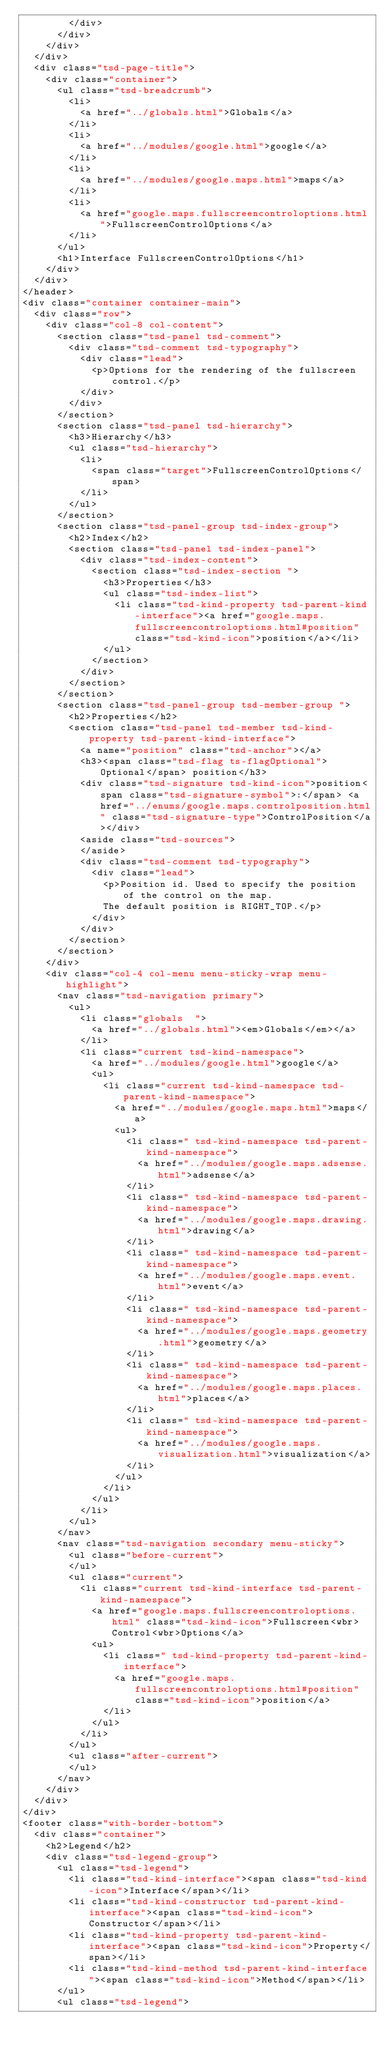<code> <loc_0><loc_0><loc_500><loc_500><_HTML_>				</div>
			</div>
		</div>
	</div>
	<div class="tsd-page-title">
		<div class="container">
			<ul class="tsd-breadcrumb">
				<li>
					<a href="../globals.html">Globals</a>
				</li>
				<li>
					<a href="../modules/google.html">google</a>
				</li>
				<li>
					<a href="../modules/google.maps.html">maps</a>
				</li>
				<li>
					<a href="google.maps.fullscreencontroloptions.html">FullscreenControlOptions</a>
				</li>
			</ul>
			<h1>Interface FullscreenControlOptions</h1>
		</div>
	</div>
</header>
<div class="container container-main">
	<div class="row">
		<div class="col-8 col-content">
			<section class="tsd-panel tsd-comment">
				<div class="tsd-comment tsd-typography">
					<div class="lead">
						<p>Options for the rendering of the fullscreen control.</p>
					</div>
				</div>
			</section>
			<section class="tsd-panel tsd-hierarchy">
				<h3>Hierarchy</h3>
				<ul class="tsd-hierarchy">
					<li>
						<span class="target">FullscreenControlOptions</span>
					</li>
				</ul>
			</section>
			<section class="tsd-panel-group tsd-index-group">
				<h2>Index</h2>
				<section class="tsd-panel tsd-index-panel">
					<div class="tsd-index-content">
						<section class="tsd-index-section ">
							<h3>Properties</h3>
							<ul class="tsd-index-list">
								<li class="tsd-kind-property tsd-parent-kind-interface"><a href="google.maps.fullscreencontroloptions.html#position" class="tsd-kind-icon">position</a></li>
							</ul>
						</section>
					</div>
				</section>
			</section>
			<section class="tsd-panel-group tsd-member-group ">
				<h2>Properties</h2>
				<section class="tsd-panel tsd-member tsd-kind-property tsd-parent-kind-interface">
					<a name="position" class="tsd-anchor"></a>
					<h3><span class="tsd-flag ts-flagOptional">Optional</span> position</h3>
					<div class="tsd-signature tsd-kind-icon">position<span class="tsd-signature-symbol">:</span> <a href="../enums/google.maps.controlposition.html" class="tsd-signature-type">ControlPosition</a></div>
					<aside class="tsd-sources">
					</aside>
					<div class="tsd-comment tsd-typography">
						<div class="lead">
							<p>Position id. Used to specify the position of the control on the map.
							The default position is RIGHT_TOP.</p>
						</div>
					</div>
				</section>
			</section>
		</div>
		<div class="col-4 col-menu menu-sticky-wrap menu-highlight">
			<nav class="tsd-navigation primary">
				<ul>
					<li class="globals  ">
						<a href="../globals.html"><em>Globals</em></a>
					</li>
					<li class="current tsd-kind-namespace">
						<a href="../modules/google.html">google</a>
						<ul>
							<li class="current tsd-kind-namespace tsd-parent-kind-namespace">
								<a href="../modules/google.maps.html">maps</a>
								<ul>
									<li class=" tsd-kind-namespace tsd-parent-kind-namespace">
										<a href="../modules/google.maps.adsense.html">adsense</a>
									</li>
									<li class=" tsd-kind-namespace tsd-parent-kind-namespace">
										<a href="../modules/google.maps.drawing.html">drawing</a>
									</li>
									<li class=" tsd-kind-namespace tsd-parent-kind-namespace">
										<a href="../modules/google.maps.event.html">event</a>
									</li>
									<li class=" tsd-kind-namespace tsd-parent-kind-namespace">
										<a href="../modules/google.maps.geometry.html">geometry</a>
									</li>
									<li class=" tsd-kind-namespace tsd-parent-kind-namespace">
										<a href="../modules/google.maps.places.html">places</a>
									</li>
									<li class=" tsd-kind-namespace tsd-parent-kind-namespace">
										<a href="../modules/google.maps.visualization.html">visualization</a>
									</li>
								</ul>
							</li>
						</ul>
					</li>
				</ul>
			</nav>
			<nav class="tsd-navigation secondary menu-sticky">
				<ul class="before-current">
				</ul>
				<ul class="current">
					<li class="current tsd-kind-interface tsd-parent-kind-namespace">
						<a href="google.maps.fullscreencontroloptions.html" class="tsd-kind-icon">Fullscreen<wbr>Control<wbr>Options</a>
						<ul>
							<li class=" tsd-kind-property tsd-parent-kind-interface">
								<a href="google.maps.fullscreencontroloptions.html#position" class="tsd-kind-icon">position</a>
							</li>
						</ul>
					</li>
				</ul>
				<ul class="after-current">
				</ul>
			</nav>
		</div>
	</div>
</div>
<footer class="with-border-bottom">
	<div class="container">
		<h2>Legend</h2>
		<div class="tsd-legend-group">
			<ul class="tsd-legend">
				<li class="tsd-kind-interface"><span class="tsd-kind-icon">Interface</span></li>
				<li class="tsd-kind-constructor tsd-parent-kind-interface"><span class="tsd-kind-icon">Constructor</span></li>
				<li class="tsd-kind-property tsd-parent-kind-interface"><span class="tsd-kind-icon">Property</span></li>
				<li class="tsd-kind-method tsd-parent-kind-interface"><span class="tsd-kind-icon">Method</span></li>
			</ul>
			<ul class="tsd-legend"></code> 